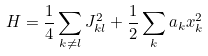Convert formula to latex. <formula><loc_0><loc_0><loc_500><loc_500>H = \frac { 1 } { 4 } \sum _ { k \neq l } J _ { k l } ^ { 2 } + \frac { 1 } { 2 } \sum _ { k } a _ { k } x _ { k } ^ { 2 }</formula> 